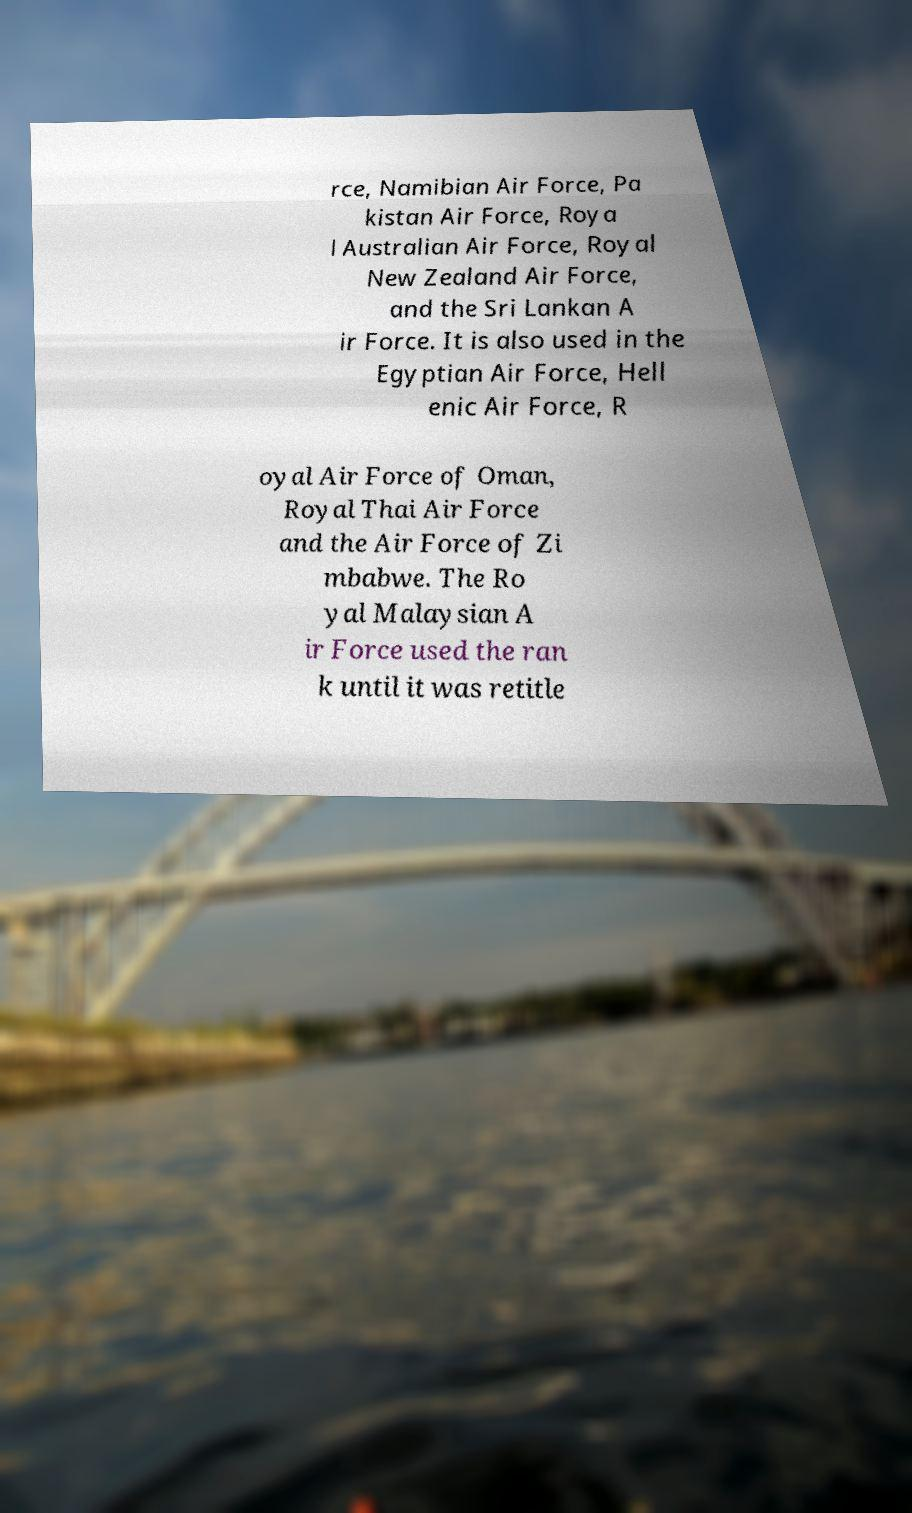Please identify and transcribe the text found in this image. rce, Namibian Air Force, Pa kistan Air Force, Roya l Australian Air Force, Royal New Zealand Air Force, and the Sri Lankan A ir Force. It is also used in the Egyptian Air Force, Hell enic Air Force, R oyal Air Force of Oman, Royal Thai Air Force and the Air Force of Zi mbabwe. The Ro yal Malaysian A ir Force used the ran k until it was retitle 